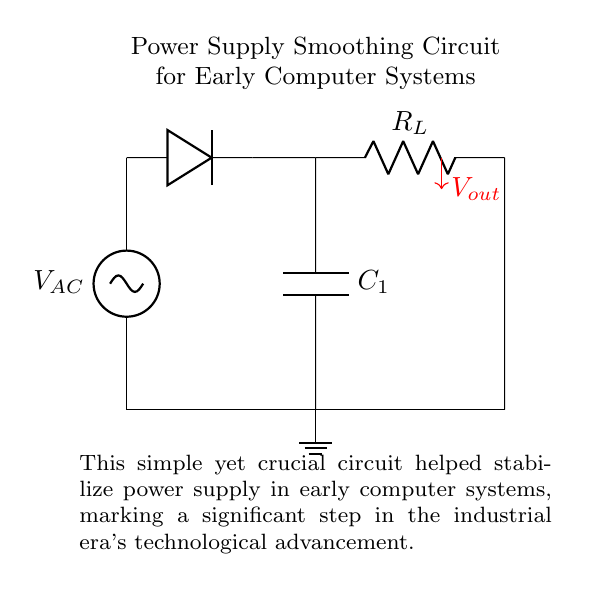What is the voltage source in this circuit? The voltage source is labeled V_AC, indicating it is an alternating current (AC) voltage supply.
Answer: V_AC What is the purpose of the capacitor labeled C1? The capacitor C1 is used for smoothing the rectified output, reducing voltage fluctuations after the rectification process.
Answer: Smoothing What component represents the load in this circuit? The load is represented by the resistor labeled R_L, which is connected in parallel with the capacitor, receiving the smoothed voltage.
Answer: R_L What is the type of current supplied by the voltage source? The type of current supplied by the voltage source V_AC is alternating current, as indicated by the label.
Answer: Alternating current How does the capacitor influence the output voltage? The capacitor charges during the voltage peaks from the rectifier and discharges during the drops, effectively leveling the output voltage, which smooths out fluctuations.
Answer: Smoothing effect What happens to the output voltage when the capacitor is removed? Removing the capacitor would lead to increased voltage fluctuations at the output, as there would be no component to smooth the rectified waveform.
Answer: Increased fluctuations What type of circuit configuration is demonstrated here? The circuit demonstrates a series configuration for the power source and rectification components, while the smoothing capacitor and load resistor are in parallel.
Answer: Series-parallel 